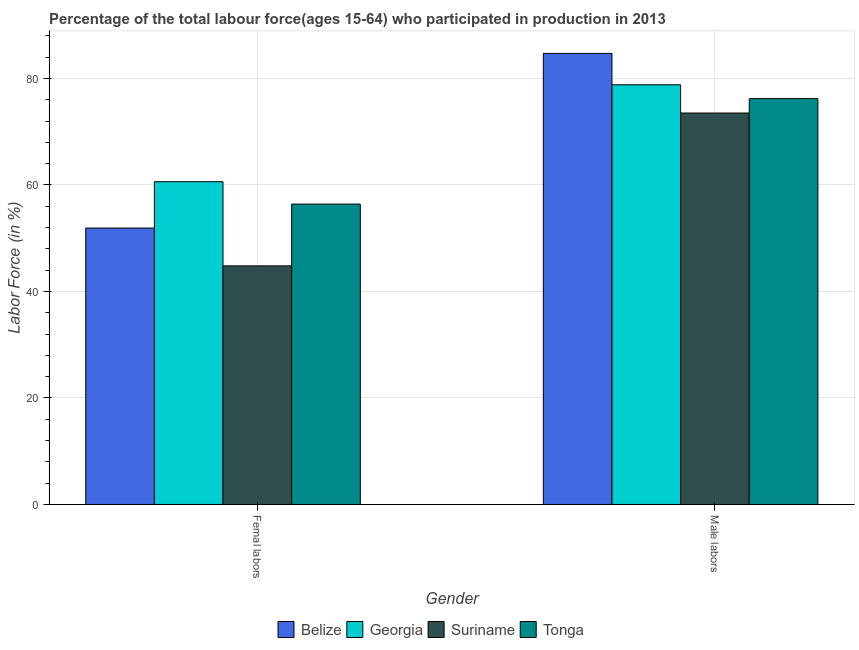How many groups of bars are there?
Make the answer very short. 2. Are the number of bars on each tick of the X-axis equal?
Make the answer very short. Yes. How many bars are there on the 2nd tick from the left?
Your response must be concise. 4. How many bars are there on the 1st tick from the right?
Provide a succinct answer. 4. What is the label of the 1st group of bars from the left?
Give a very brief answer. Femal labors. What is the percentage of female labor force in Georgia?
Keep it short and to the point. 60.6. Across all countries, what is the maximum percentage of male labour force?
Offer a terse response. 84.7. Across all countries, what is the minimum percentage of male labour force?
Your answer should be compact. 73.5. In which country was the percentage of female labor force maximum?
Your answer should be compact. Georgia. In which country was the percentage of female labor force minimum?
Make the answer very short. Suriname. What is the total percentage of female labor force in the graph?
Provide a succinct answer. 213.7. What is the difference between the percentage of female labor force in Suriname and that in Georgia?
Offer a terse response. -15.8. What is the difference between the percentage of male labour force in Tonga and the percentage of female labor force in Belize?
Your answer should be very brief. 24.3. What is the average percentage of male labour force per country?
Ensure brevity in your answer.  78.3. What is the difference between the percentage of male labour force and percentage of female labor force in Georgia?
Offer a very short reply. 18.2. What is the ratio of the percentage of male labour force in Tonga to that in Georgia?
Your response must be concise. 0.97. Is the percentage of male labour force in Tonga less than that in Belize?
Give a very brief answer. Yes. What does the 2nd bar from the left in Femal labors represents?
Your answer should be very brief. Georgia. What does the 1st bar from the right in Male labors represents?
Provide a short and direct response. Tonga. How many countries are there in the graph?
Provide a short and direct response. 4. What is the difference between two consecutive major ticks on the Y-axis?
Your response must be concise. 20. Are the values on the major ticks of Y-axis written in scientific E-notation?
Your response must be concise. No. Where does the legend appear in the graph?
Make the answer very short. Bottom center. How many legend labels are there?
Your answer should be very brief. 4. How are the legend labels stacked?
Provide a succinct answer. Horizontal. What is the title of the graph?
Offer a very short reply. Percentage of the total labour force(ages 15-64) who participated in production in 2013. Does "Kuwait" appear as one of the legend labels in the graph?
Provide a succinct answer. No. What is the label or title of the Y-axis?
Offer a terse response. Labor Force (in %). What is the Labor Force (in %) of Belize in Femal labors?
Offer a very short reply. 51.9. What is the Labor Force (in %) in Georgia in Femal labors?
Offer a terse response. 60.6. What is the Labor Force (in %) of Suriname in Femal labors?
Ensure brevity in your answer.  44.8. What is the Labor Force (in %) in Tonga in Femal labors?
Keep it short and to the point. 56.4. What is the Labor Force (in %) in Belize in Male labors?
Make the answer very short. 84.7. What is the Labor Force (in %) of Georgia in Male labors?
Ensure brevity in your answer.  78.8. What is the Labor Force (in %) of Suriname in Male labors?
Your answer should be very brief. 73.5. What is the Labor Force (in %) in Tonga in Male labors?
Provide a succinct answer. 76.2. Across all Gender, what is the maximum Labor Force (in %) of Belize?
Offer a terse response. 84.7. Across all Gender, what is the maximum Labor Force (in %) in Georgia?
Provide a succinct answer. 78.8. Across all Gender, what is the maximum Labor Force (in %) of Suriname?
Your answer should be very brief. 73.5. Across all Gender, what is the maximum Labor Force (in %) of Tonga?
Make the answer very short. 76.2. Across all Gender, what is the minimum Labor Force (in %) of Belize?
Offer a very short reply. 51.9. Across all Gender, what is the minimum Labor Force (in %) in Georgia?
Provide a succinct answer. 60.6. Across all Gender, what is the minimum Labor Force (in %) of Suriname?
Offer a very short reply. 44.8. Across all Gender, what is the minimum Labor Force (in %) in Tonga?
Provide a short and direct response. 56.4. What is the total Labor Force (in %) in Belize in the graph?
Give a very brief answer. 136.6. What is the total Labor Force (in %) of Georgia in the graph?
Your answer should be very brief. 139.4. What is the total Labor Force (in %) of Suriname in the graph?
Your answer should be very brief. 118.3. What is the total Labor Force (in %) of Tonga in the graph?
Offer a terse response. 132.6. What is the difference between the Labor Force (in %) of Belize in Femal labors and that in Male labors?
Your answer should be very brief. -32.8. What is the difference between the Labor Force (in %) of Georgia in Femal labors and that in Male labors?
Provide a short and direct response. -18.2. What is the difference between the Labor Force (in %) in Suriname in Femal labors and that in Male labors?
Your response must be concise. -28.7. What is the difference between the Labor Force (in %) of Tonga in Femal labors and that in Male labors?
Your answer should be very brief. -19.8. What is the difference between the Labor Force (in %) of Belize in Femal labors and the Labor Force (in %) of Georgia in Male labors?
Your answer should be very brief. -26.9. What is the difference between the Labor Force (in %) in Belize in Femal labors and the Labor Force (in %) in Suriname in Male labors?
Provide a succinct answer. -21.6. What is the difference between the Labor Force (in %) in Belize in Femal labors and the Labor Force (in %) in Tonga in Male labors?
Offer a very short reply. -24.3. What is the difference between the Labor Force (in %) of Georgia in Femal labors and the Labor Force (in %) of Tonga in Male labors?
Give a very brief answer. -15.6. What is the difference between the Labor Force (in %) of Suriname in Femal labors and the Labor Force (in %) of Tonga in Male labors?
Your response must be concise. -31.4. What is the average Labor Force (in %) in Belize per Gender?
Offer a terse response. 68.3. What is the average Labor Force (in %) in Georgia per Gender?
Offer a very short reply. 69.7. What is the average Labor Force (in %) of Suriname per Gender?
Ensure brevity in your answer.  59.15. What is the average Labor Force (in %) in Tonga per Gender?
Ensure brevity in your answer.  66.3. What is the difference between the Labor Force (in %) in Belize and Labor Force (in %) in Tonga in Femal labors?
Your response must be concise. -4.5. What is the difference between the Labor Force (in %) of Georgia and Labor Force (in %) of Suriname in Femal labors?
Provide a short and direct response. 15.8. What is the difference between the Labor Force (in %) in Belize and Labor Force (in %) in Tonga in Male labors?
Offer a terse response. 8.5. What is the difference between the Labor Force (in %) in Georgia and Labor Force (in %) in Suriname in Male labors?
Your response must be concise. 5.3. What is the ratio of the Labor Force (in %) of Belize in Femal labors to that in Male labors?
Offer a terse response. 0.61. What is the ratio of the Labor Force (in %) in Georgia in Femal labors to that in Male labors?
Make the answer very short. 0.77. What is the ratio of the Labor Force (in %) in Suriname in Femal labors to that in Male labors?
Provide a succinct answer. 0.61. What is the ratio of the Labor Force (in %) of Tonga in Femal labors to that in Male labors?
Your answer should be compact. 0.74. What is the difference between the highest and the second highest Labor Force (in %) of Belize?
Ensure brevity in your answer.  32.8. What is the difference between the highest and the second highest Labor Force (in %) of Georgia?
Offer a terse response. 18.2. What is the difference between the highest and the second highest Labor Force (in %) in Suriname?
Give a very brief answer. 28.7. What is the difference between the highest and the second highest Labor Force (in %) of Tonga?
Ensure brevity in your answer.  19.8. What is the difference between the highest and the lowest Labor Force (in %) of Belize?
Your answer should be compact. 32.8. What is the difference between the highest and the lowest Labor Force (in %) of Georgia?
Offer a very short reply. 18.2. What is the difference between the highest and the lowest Labor Force (in %) of Suriname?
Give a very brief answer. 28.7. What is the difference between the highest and the lowest Labor Force (in %) in Tonga?
Give a very brief answer. 19.8. 